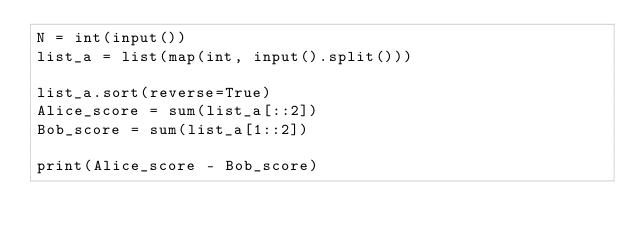<code> <loc_0><loc_0><loc_500><loc_500><_Python_>N = int(input())
list_a = list(map(int, input().split()))

list_a.sort(reverse=True)
Alice_score = sum(list_a[::2])
Bob_score = sum(list_a[1::2])

print(Alice_score - Bob_score)</code> 